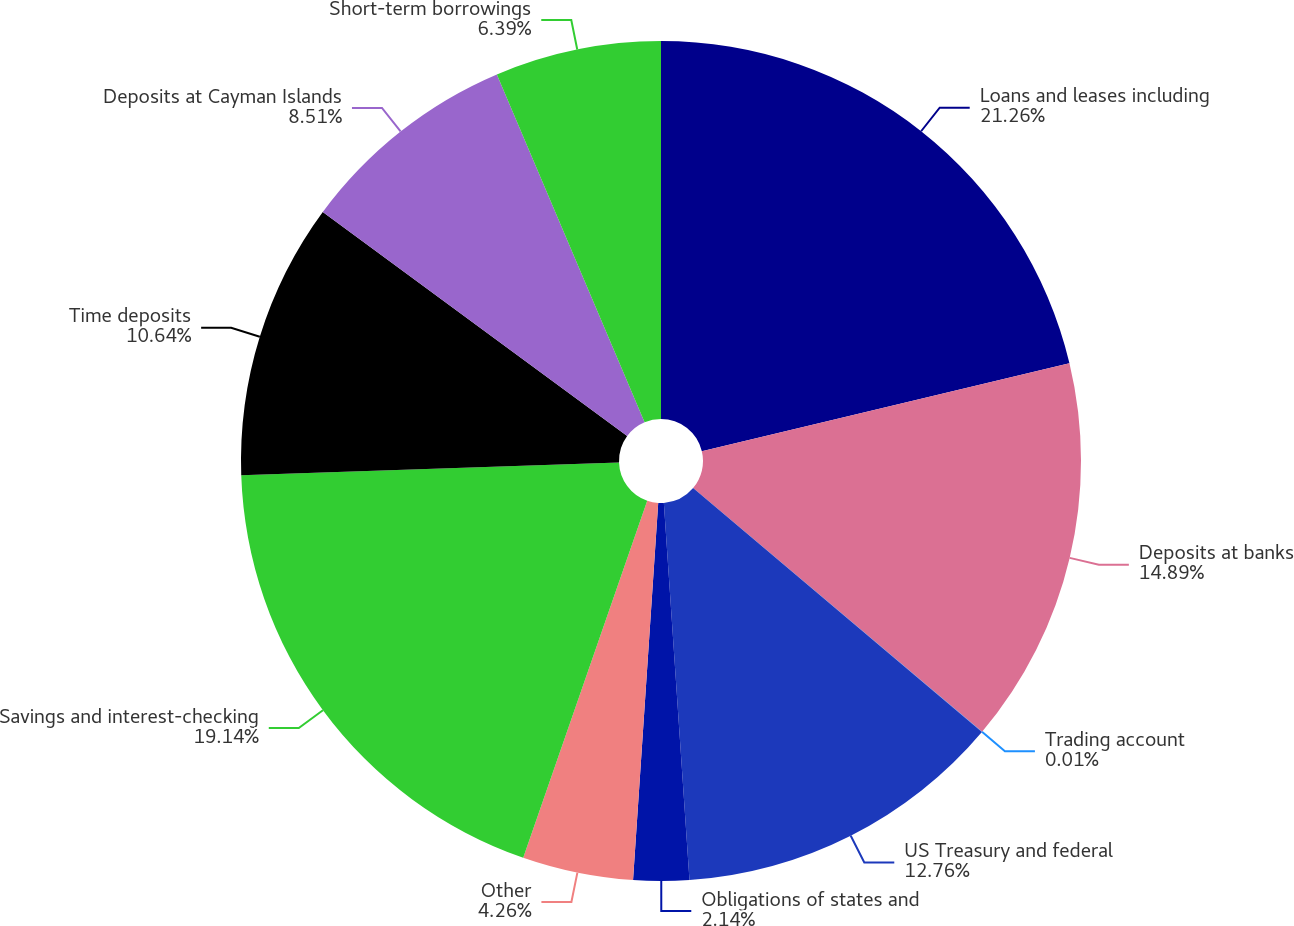<chart> <loc_0><loc_0><loc_500><loc_500><pie_chart><fcel>Loans and leases including<fcel>Deposits at banks<fcel>Trading account<fcel>US Treasury and federal<fcel>Obligations of states and<fcel>Other<fcel>Savings and interest-checking<fcel>Time deposits<fcel>Deposits at Cayman Islands<fcel>Short-term borrowings<nl><fcel>21.26%<fcel>14.89%<fcel>0.01%<fcel>12.76%<fcel>2.14%<fcel>4.26%<fcel>19.14%<fcel>10.64%<fcel>8.51%<fcel>6.39%<nl></chart> 